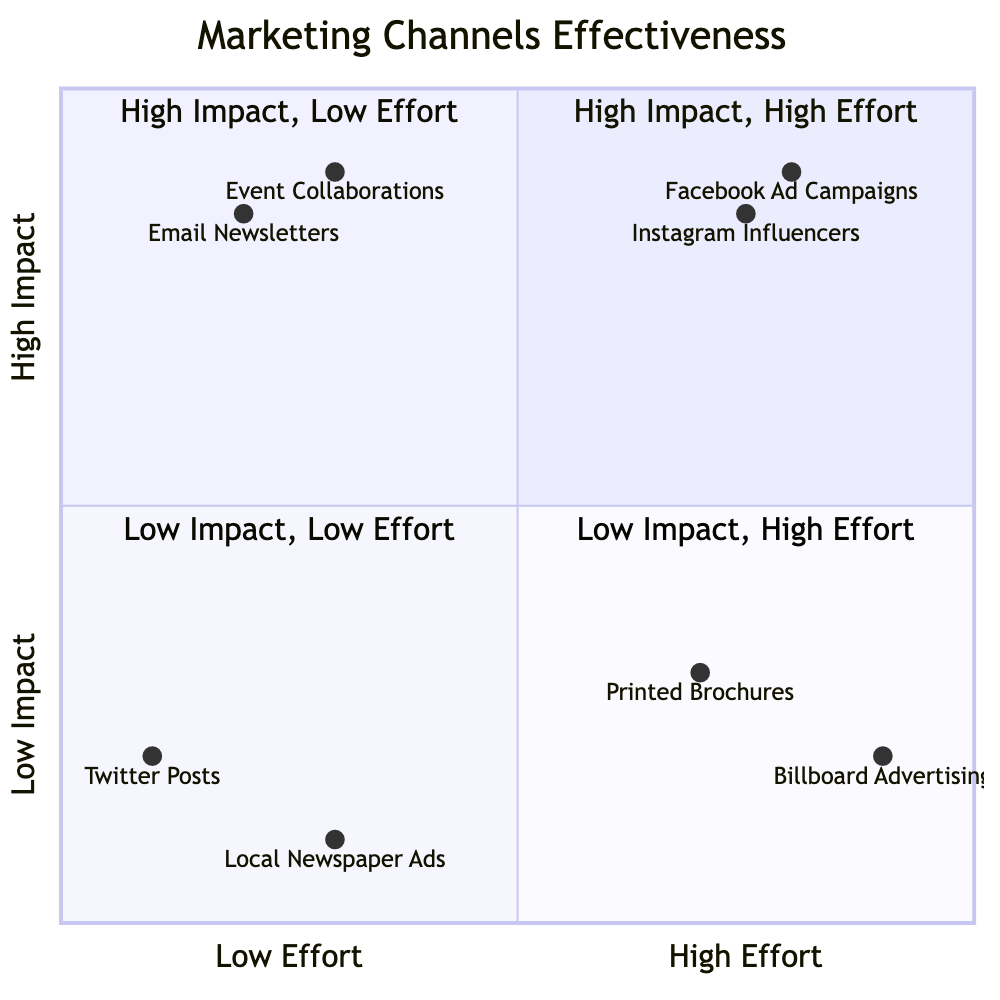What are the elements in the High Impact, High Effort quadrant? The High Impact, High Effort quadrant includes Instagram Influencers and Facebook Ad Campaigns. By referencing the diagram, these are the two elements listed specifically in this quadrant.
Answer: Instagram Influencers, Facebook Ad Campaigns Which marketing channel has the lowest impact and also requires low effort? In the Low Impact, Low Effort quadrant, the elements are Twitter Posts and Local Newspaper Ads. By examining the diagram, Twitter Posts is identified as the lowest impact and low effort channel.
Answer: Twitter Posts How many elements are in the High Impact, Low Effort quadrant? The High Impact, Low Effort quadrant contains two elements: Email Newsletters and Event Collaborations with Local Film Festivals. Counting these, we determine that there are two elements present.
Answer: 2 What is the impact level of Printed Brochures? According to the diagram, Printed Brochures is located in the Low Impact, High Effort quadrant. This indicates that it has a low impact based on the information provided.
Answer: Low Impact Which marketing channel requires the highest effort? Facebook Ad Campaigns and Instagram Influencers, located in the High Impact, High Effort quadrant, indicate extensive effort is needed. By assessing the effort levels, Facebook Ad Campaigns requires the highest effort among the listed channels.
Answer: Facebook Ad Campaigns Is Local Newspaper Ads considered high impact? In the diagram, Local Newspaper Ads are placed in the Low Impact, Low Effort quadrant, indicating that they do not generate significant effects in terms of attendance or sales.
Answer: No Which channel has higher impact: Email Newsletters or Twitter Posts? By comparing the quadrants, Email Newsletters is found in the High Impact, Low Effort quadrant, while Twitter Posts is in the Low Impact, Low Effort quadrant. This indicates that Email Newsletters has a higher impact level than Twitter Posts.
Answer: Email Newsletters What do Facebook Ad Campaigns and Instagram Influencers have in common? Both Facebook Ad Campaigns and Instagram Influencers are positioned in the High Impact, High Effort quadrant, indicating they share similar characteristics of high impact and requiring considerable effort to implement.
Answer: High Impact, High Effort 